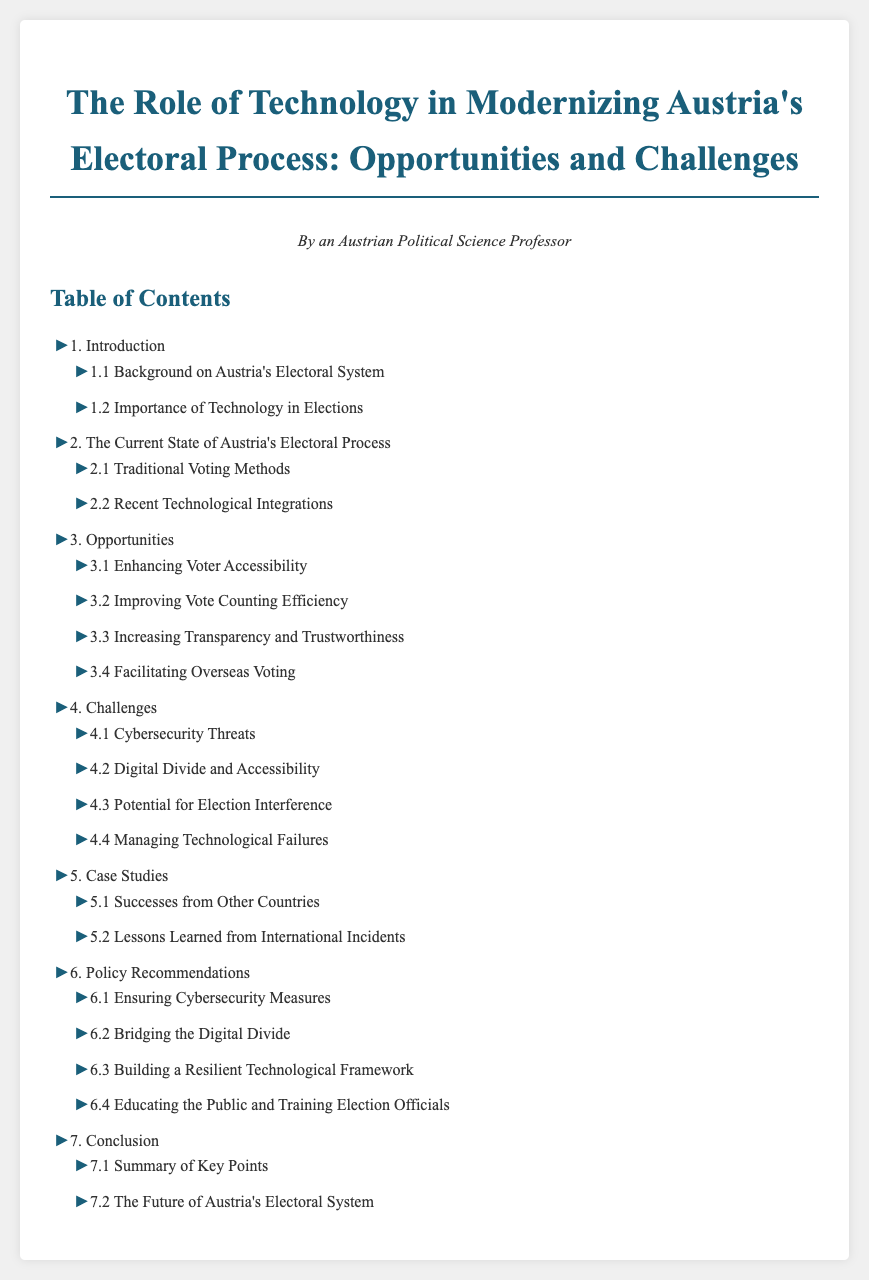What is the title of the document? The title is provided in the heading of the document.
Answer: The Role of Technology in Modernizing Austria's Electoral Process: Opportunities and Challenges Who is the author of the document? The author is mentioned at the top of the document.
Answer: An Austrian Political Science Professor What is the first section of the Table of Contents? The first section is listed at the beginning of the Table of Contents.
Answer: Introduction How many subsections are in the Opportunities section? The number of subsections is counted under the Opportunities section in the Table of Contents.
Answer: Four What is one challenge listed in the document? This challenge can be found in the Challenges section of the Table of Contents.
Answer: Cybersecurity Threats What is mentioned as a benefit of technology in elections? The document lists specific benefits under the Opportunities section.
Answer: Enhancing Voter Accessibility What does the document suggest about the future of Austria's electoral system? This information is found in the conclusion section of the Table of Contents.
Answer: The Future of Austria's Electoral System Which section discusses international incidents? This information is detailed in the Case Studies section.
Answer: Lessons Learned from International Incidents 